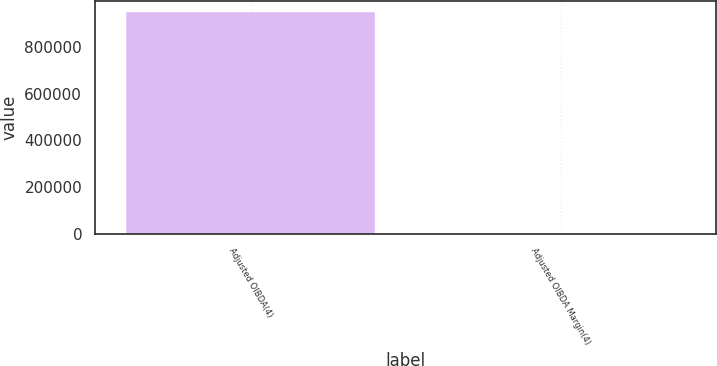<chart> <loc_0><loc_0><loc_500><loc_500><bar_chart><fcel>Adjusted OIBDA(4)<fcel>Adjusted OIBDA Margin(4)<nl><fcel>950439<fcel>31.5<nl></chart> 